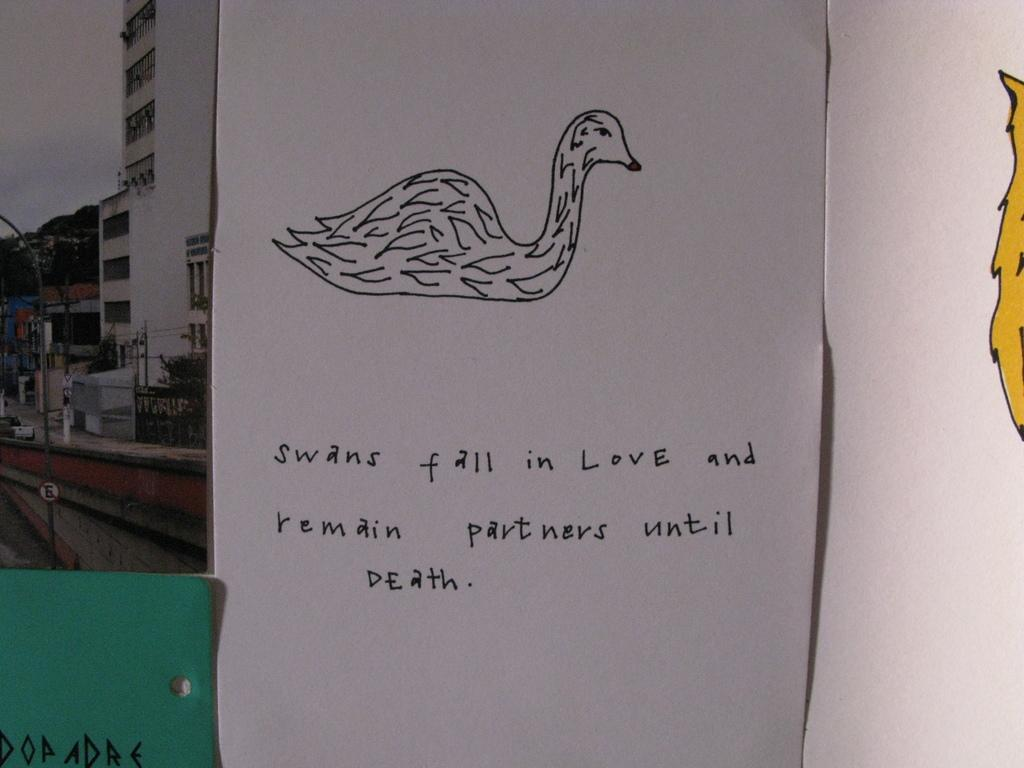What is depicted on the white paper in the image? There is a drawing on a white paper in the image. What can be found on the drawing itself? There is text on the drawing. What can be seen in the distance in the image? There are buildings, trees, and the sky visible in the background of the image. What type of baseball is being worn by the father in the image? There is no baseball or father present in the image; it features a drawing on a white paper with text and a background of buildings, trees, and the sky. 